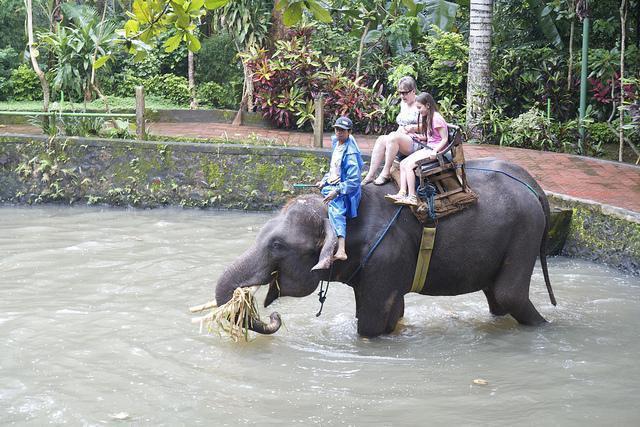How many people are seated on top of the elephant eating in the pool?
Indicate the correct response and explain using: 'Answer: answer
Rationale: rationale.'
Options: Three, two, six, four. Answer: three.
Rationale: There are three people 